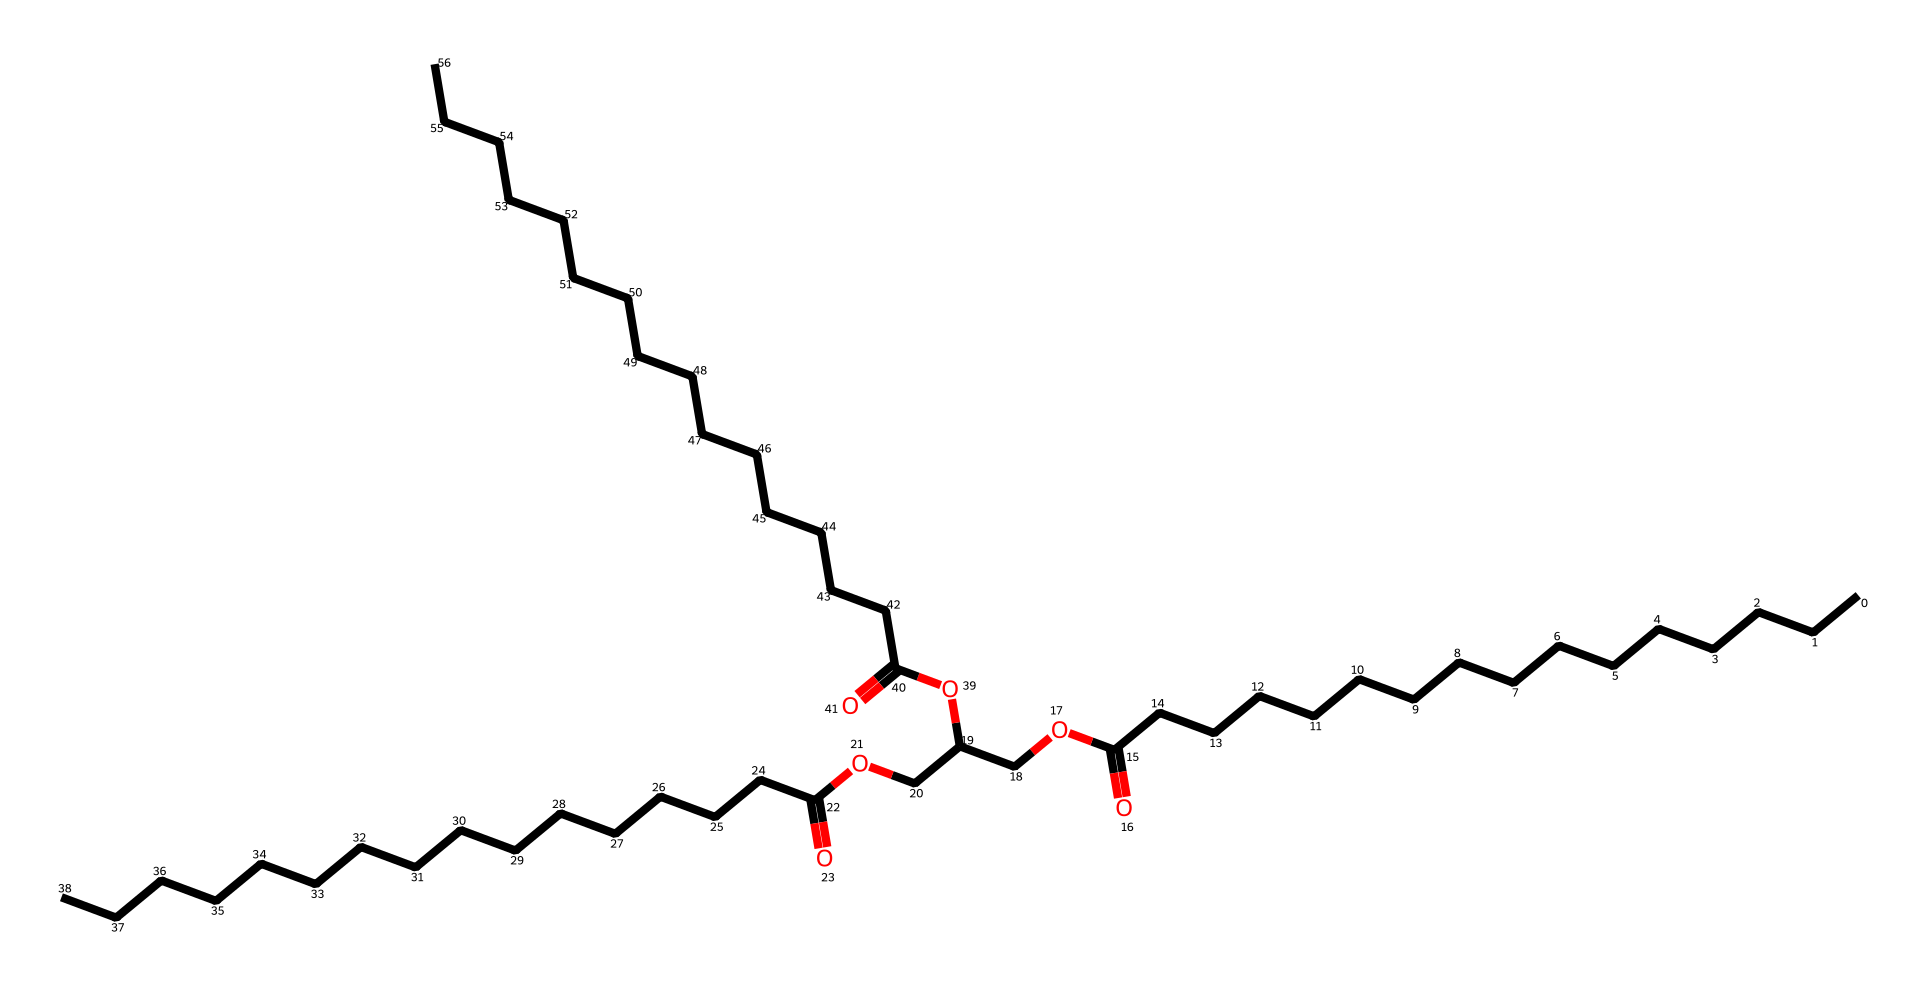What is the main functional group present in this compound? This structure reveals -COO- groups, which are characteristic of esters. The presence of two carbonyl (C=O) oxygen atoms directly linked to single-bonded oxygen (O) indicates the ester functional group.
Answer: ester How many carbon atoms are in this chemical structure? By tracing the longest carbon chain and including all carbon atoms from the functional groups, we count a total of 27 carbon atoms in the entire molecular structure.
Answer: 27 What type of ester is primarily represented in this structure? This compound consists of fatty acid esters derived from long-chain fatty acids and alcohols usually found in biodiesel, which means it is a fatty acid methyl ester.
Answer: fatty acid methyl ester Which part of the structure indicates the presence of long-chain hydrocarbons? The extended linear chains with numerous carbon (C) atoms and hydrogen (H) atoms indicate long hydrocarbon chains typically derived from vegetable oils and animal fats, which are utilized in biodiesel.
Answer: long hydrocarbon chains What is the significance of the -O- (ether) linkages in biodiesel? The -O- ether linkages serve to connect the fatty acid chains to the glycerol backbone in biodiesel, facilitating the emulsification and physical properties of the fuel, enhancing its combustion qualities.
Answer: emulsification How many ester functional groups can be identified in this compound? Upon analyzing the structure, we observe three distinct -COO- ester functional groups, indicating that the molecule has multiple sites that can take part in chemical reactions typical of esters.
Answer: 3 